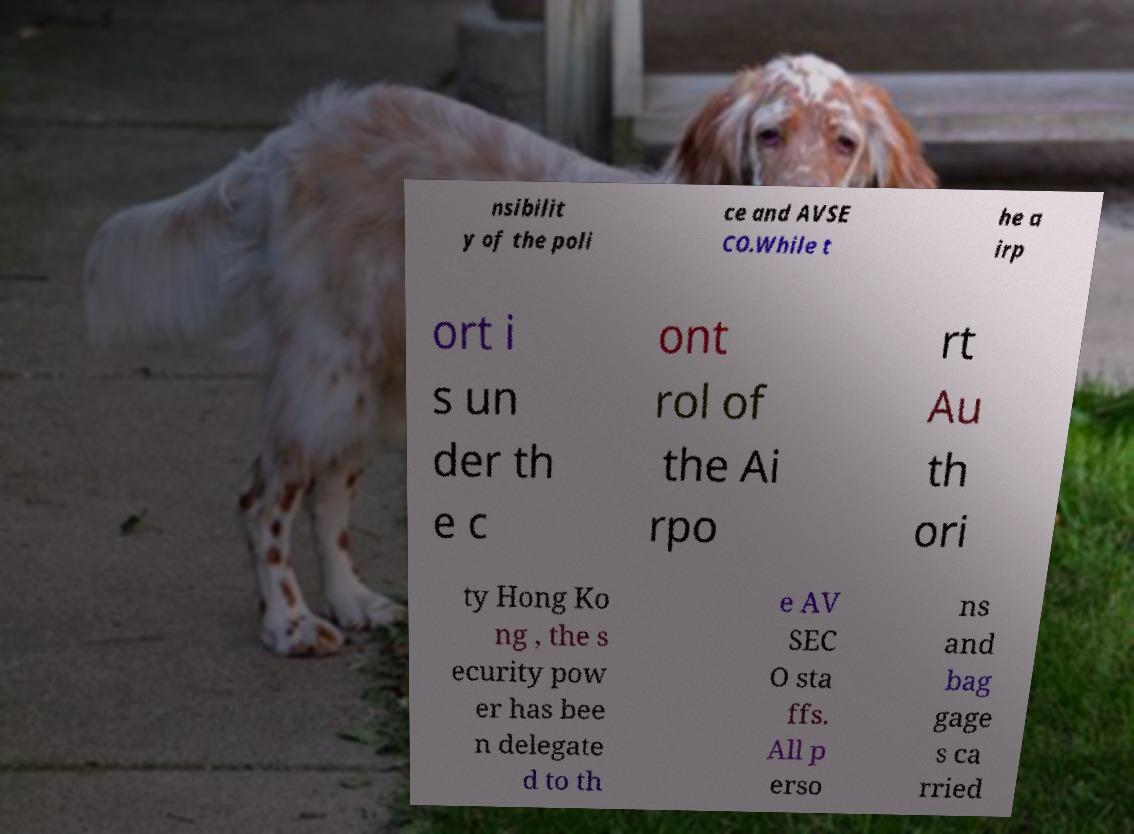Could you assist in decoding the text presented in this image and type it out clearly? nsibilit y of the poli ce and AVSE CO.While t he a irp ort i s un der th e c ont rol of the Ai rpo rt Au th ori ty Hong Ko ng , the s ecurity pow er has bee n delegate d to th e AV SEC O sta ffs. All p erso ns and bag gage s ca rried 